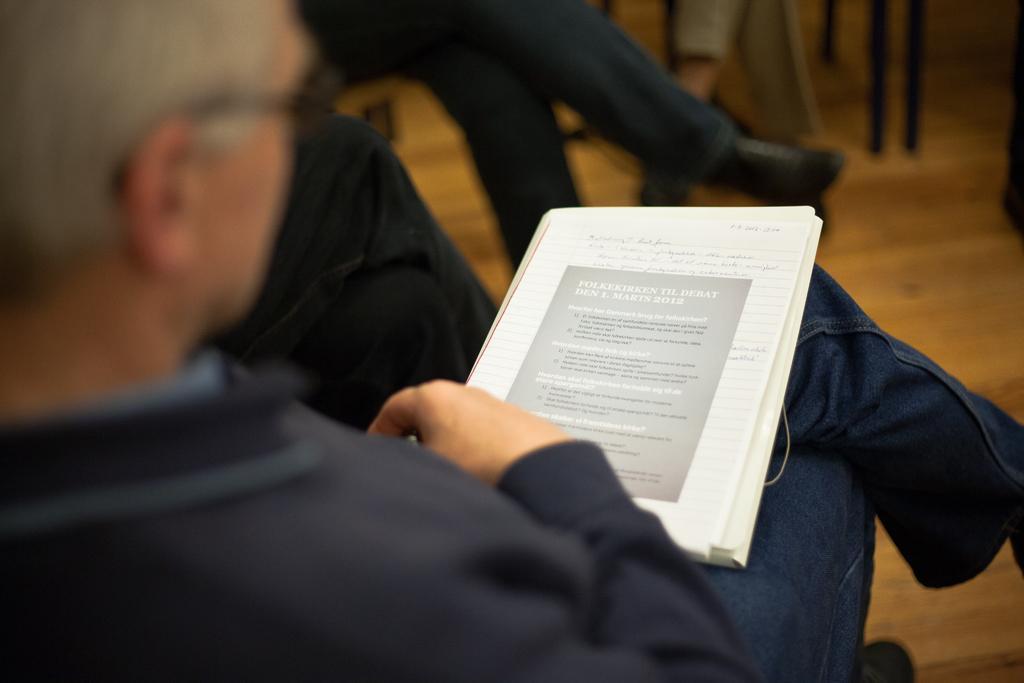Can you describe this image briefly? In the image we can see there is a person sitting on the chair and there is a book on his lap and beside there are other people sitting on the chair. 